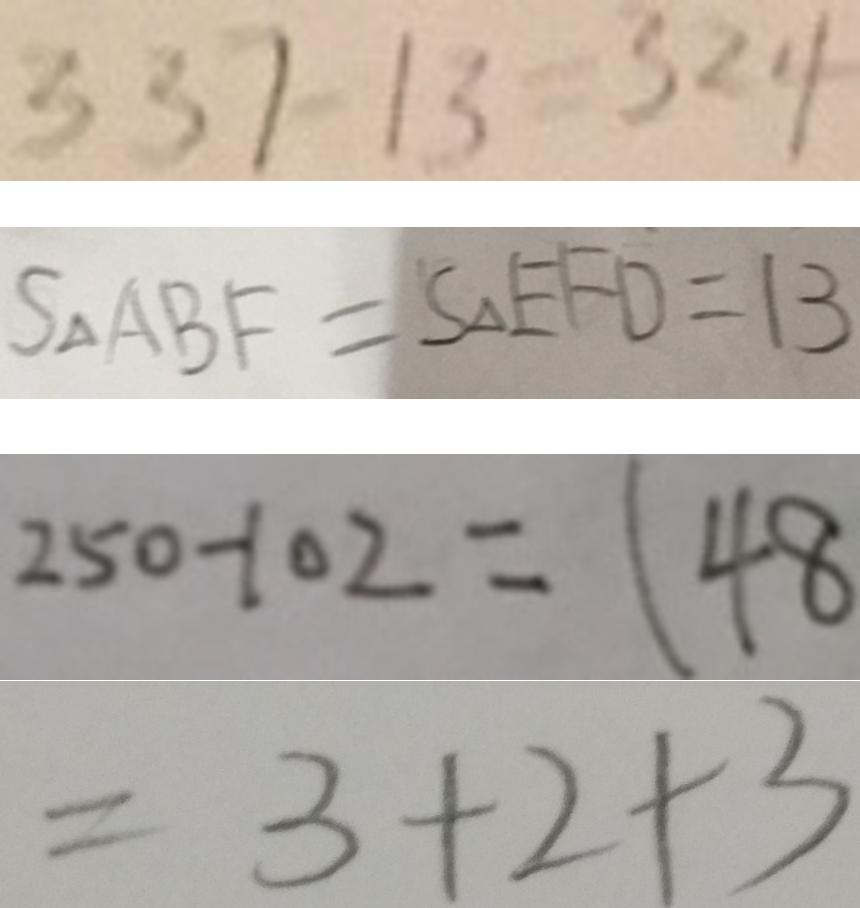<formula> <loc_0><loc_0><loc_500><loc_500>3 3 7 - 1 3 = 3 2 4 
 S _ { \Delta } A B F = S _ { \Delta } E F D = 1 3 
 2 5 0 - 1 0 2 = 1 4 8 
 = 3 + 2 + 3</formula> 